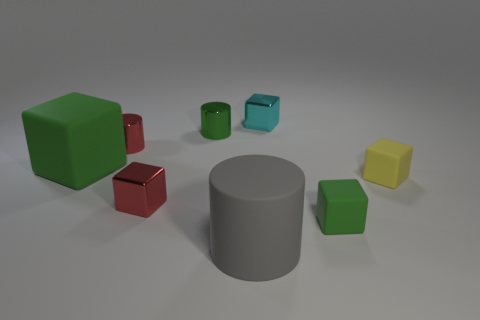Subtract all red cubes. How many cubes are left? 4 Subtract all small red blocks. How many blocks are left? 4 Subtract all blue cubes. Subtract all cyan balls. How many cubes are left? 5 Add 2 tiny brown things. How many objects exist? 10 Subtract all cubes. How many objects are left? 3 Add 6 gray matte things. How many gray matte things exist? 7 Subtract 0 gray spheres. How many objects are left? 8 Subtract all large things. Subtract all small red metal cubes. How many objects are left? 5 Add 2 tiny red things. How many tiny red things are left? 4 